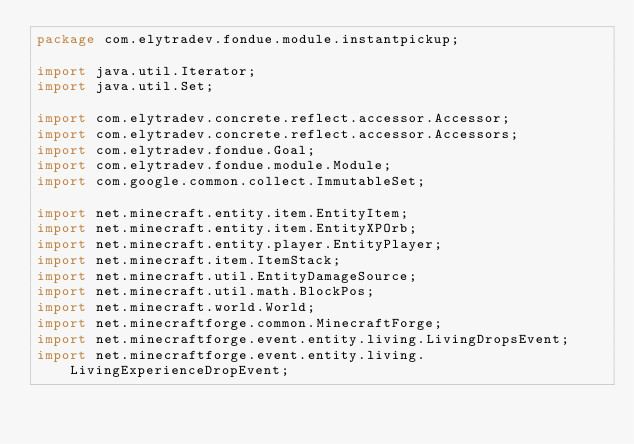Convert code to text. <code><loc_0><loc_0><loc_500><loc_500><_Java_>package com.elytradev.fondue.module.instantpickup;

import java.util.Iterator;
import java.util.Set;

import com.elytradev.concrete.reflect.accessor.Accessor;
import com.elytradev.concrete.reflect.accessor.Accessors;
import com.elytradev.fondue.Goal;
import com.elytradev.fondue.module.Module;
import com.google.common.collect.ImmutableSet;

import net.minecraft.entity.item.EntityItem;
import net.minecraft.entity.item.EntityXPOrb;
import net.minecraft.entity.player.EntityPlayer;
import net.minecraft.item.ItemStack;
import net.minecraft.util.EntityDamageSource;
import net.minecraft.util.math.BlockPos;
import net.minecraft.world.World;
import net.minecraftforge.common.MinecraftForge;
import net.minecraftforge.event.entity.living.LivingDropsEvent;
import net.minecraftforge.event.entity.living.LivingExperienceDropEvent;</code> 